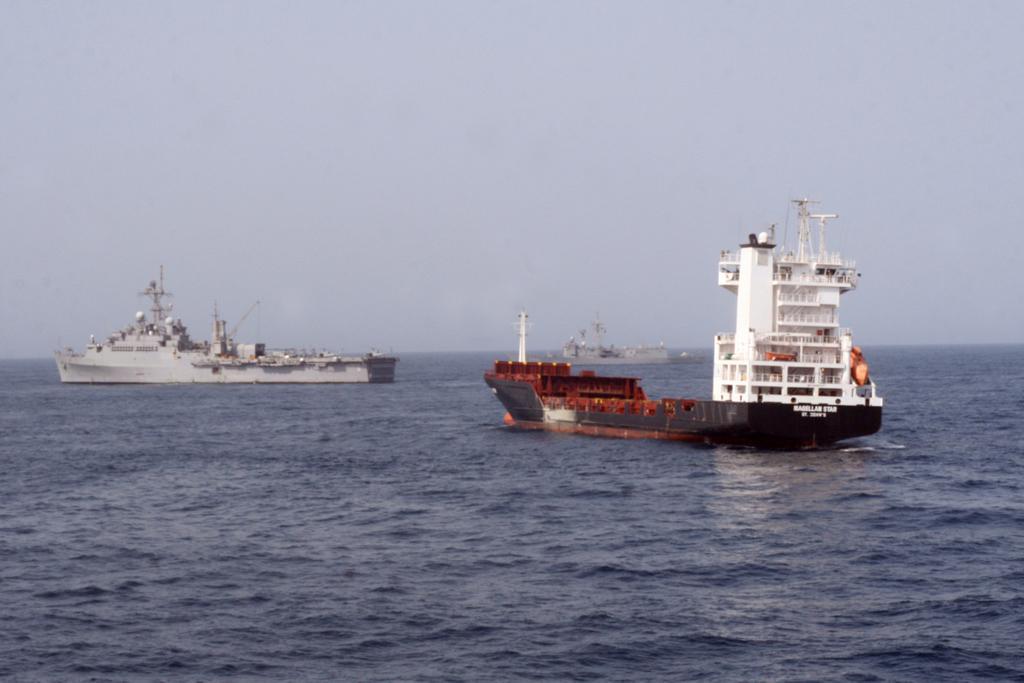How would you summarize this image in a sentence or two? In this image, we can see ships on the water and at the top, there is sky. 